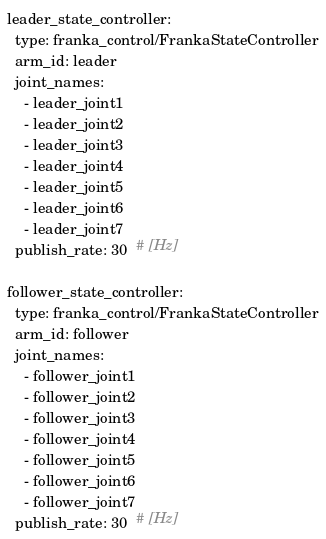<code> <loc_0><loc_0><loc_500><loc_500><_YAML_>leader_state_controller:
  type: franka_control/FrankaStateController
  arm_id: leader
  joint_names:
    - leader_joint1
    - leader_joint2
    - leader_joint3
    - leader_joint4
    - leader_joint5
    - leader_joint6
    - leader_joint7
  publish_rate: 30  # [Hz]

follower_state_controller:
  type: franka_control/FrankaStateController
  arm_id: follower
  joint_names:
    - follower_joint1
    - follower_joint2
    - follower_joint3
    - follower_joint4
    - follower_joint5
    - follower_joint6
    - follower_joint7
  publish_rate: 30  # [Hz]
</code> 